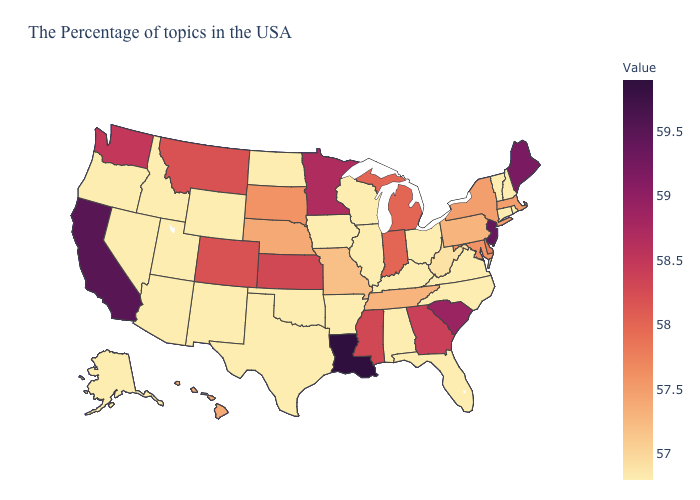Among the states that border Wisconsin , which have the highest value?
Be succinct. Minnesota. Is the legend a continuous bar?
Write a very short answer. Yes. Among the states that border New Hampshire , which have the lowest value?
Write a very short answer. Vermont. Among the states that border Kentucky , which have the lowest value?
Be succinct. Virginia, Ohio, Illinois. Among the states that border Tennessee , which have the lowest value?
Give a very brief answer. Virginia, North Carolina, Kentucky, Alabama, Arkansas. Among the states that border Wyoming , which have the highest value?
Be succinct. Colorado, Montana. Does the map have missing data?
Keep it brief. No. Which states hav the highest value in the MidWest?
Keep it brief. Minnesota. 